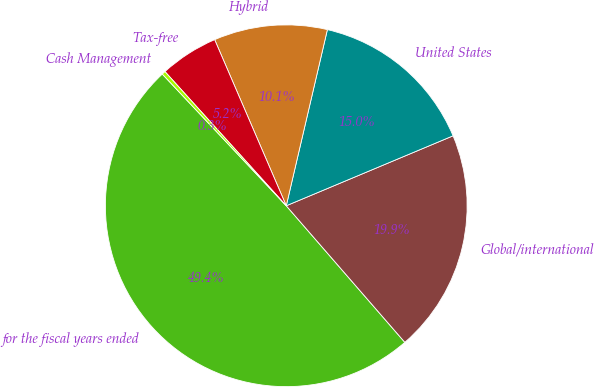<chart> <loc_0><loc_0><loc_500><loc_500><pie_chart><fcel>for the fiscal years ended<fcel>Global/international<fcel>United States<fcel>Hybrid<fcel>Tax-free<fcel>Cash Management<nl><fcel>49.36%<fcel>19.94%<fcel>15.03%<fcel>10.13%<fcel>5.22%<fcel>0.32%<nl></chart> 